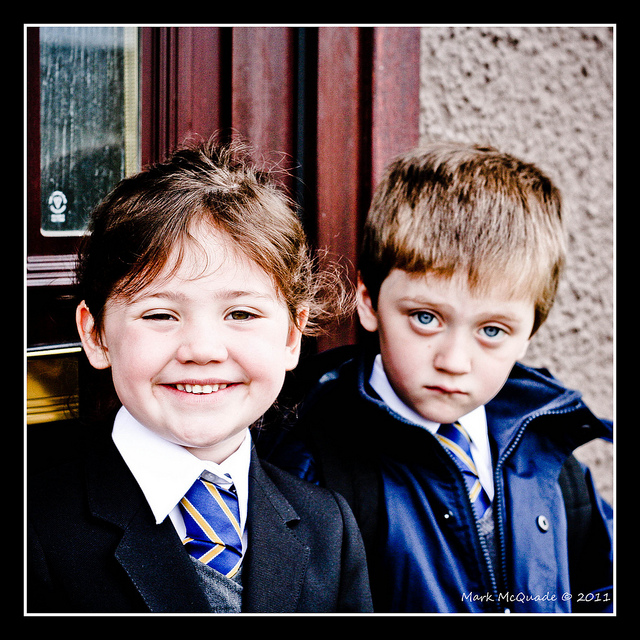<image>What kind of knot is tied in this tie? I don't know what kind of knot is tied in this tie. It can be a regular, standard tie knot or a windsor. What kind of knot is tied in this tie? I am not sure what kind of knot is tied in this tie. It can be seen as regular, neck, standard tie knot or windsor. 